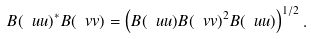<formula> <loc_0><loc_0><loc_500><loc_500>B ( \ u u ) ^ { * } B ( \ v v ) = \left ( B ( \ u u ) B ( \ v v ) ^ { 2 } B ( \ u u ) \right ) ^ { 1 / 2 } .</formula> 